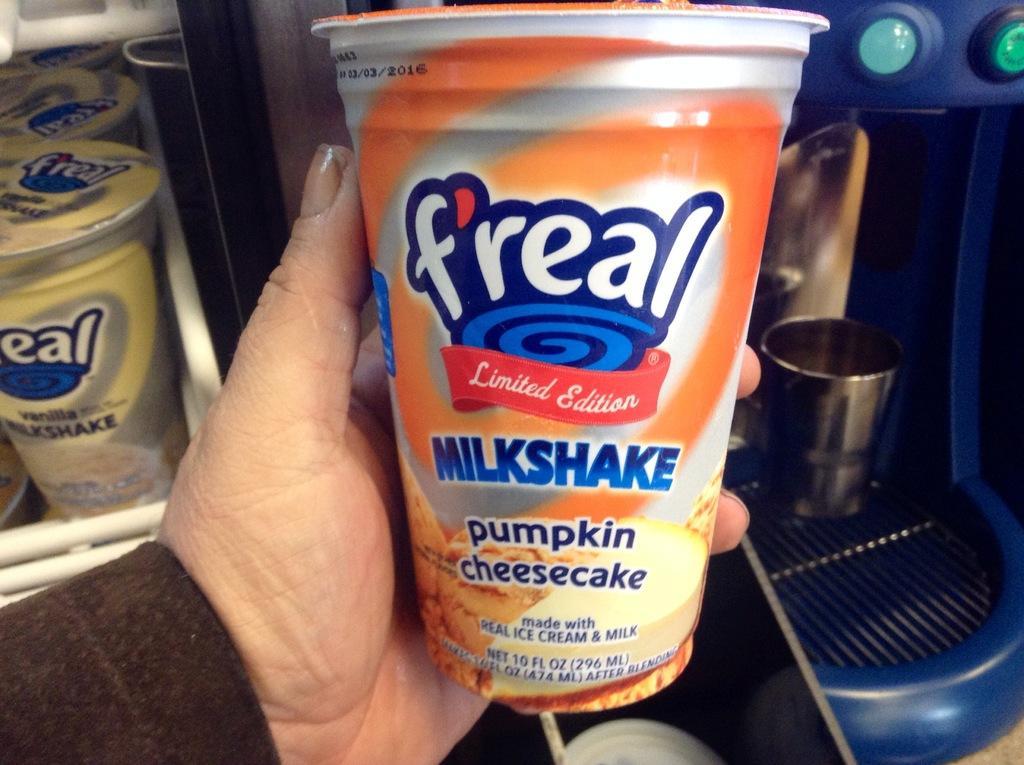How would you summarize this image in a sentence or two? In this image there are glasses and in the front there is a hand of the person which is holding a glass and on the right side there is a machine which is blue in colour. 